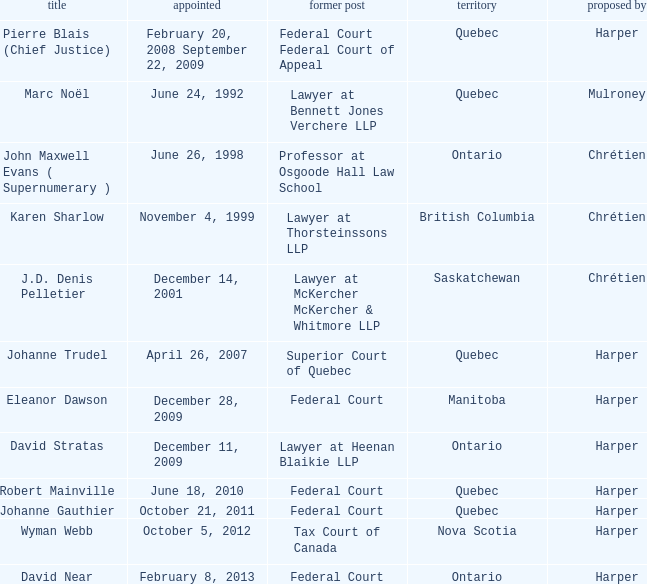Parse the table in full. {'header': ['title', 'appointed', 'former post', 'territory', 'proposed by'], 'rows': [['Pierre Blais (Chief Justice)', 'February 20, 2008 September 22, 2009', 'Federal Court Federal Court of Appeal', 'Quebec', 'Harper'], ['Marc Noël', 'June 24, 1992', 'Lawyer at Bennett Jones Verchere LLP', 'Quebec', 'Mulroney'], ['John Maxwell Evans ( Supernumerary )', 'June 26, 1998', 'Professor at Osgoode Hall Law School', 'Ontario', 'Chrétien'], ['Karen Sharlow', 'November 4, 1999', 'Lawyer at Thorsteinssons LLP', 'British Columbia', 'Chrétien'], ['J.D. Denis Pelletier', 'December 14, 2001', 'Lawyer at McKercher McKercher & Whitmore LLP', 'Saskatchewan', 'Chrétien'], ['Johanne Trudel', 'April 26, 2007', 'Superior Court of Quebec', 'Quebec', 'Harper'], ['Eleanor Dawson', 'December 28, 2009', 'Federal Court', 'Manitoba', 'Harper'], ['David Stratas', 'December 11, 2009', 'Lawyer at Heenan Blaikie LLP', 'Ontario', 'Harper'], ['Robert Mainville', 'June 18, 2010', 'Federal Court', 'Quebec', 'Harper'], ['Johanne Gauthier', 'October 21, 2011', 'Federal Court', 'Quebec', 'Harper'], ['Wyman Webb', 'October 5, 2012', 'Tax Court of Canada', 'Nova Scotia', 'Harper'], ['David Near', 'February 8, 2013', 'Federal Court', 'Ontario', 'Harper']]} Who was appointed on October 21, 2011 from Quebec? Johanne Gauthier. 